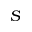Convert formula to latex. <formula><loc_0><loc_0><loc_500><loc_500>S</formula> 